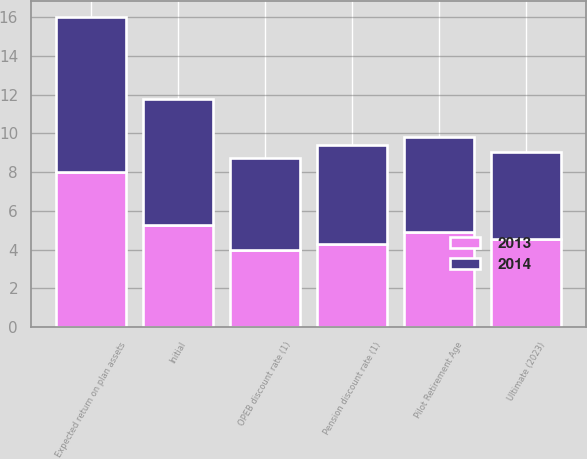Convert chart to OTSL. <chart><loc_0><loc_0><loc_500><loc_500><stacked_bar_chart><ecel><fcel>Pension discount rate (1)<fcel>OPEB discount rate (1)<fcel>Expected return on plan assets<fcel>Initial<fcel>Ultimate (2023)<fcel>Pilot Retirement Age<nl><fcel>2013<fcel>4.3<fcel>4<fcel>8<fcel>5.25<fcel>4.55<fcel>4.905<nl><fcel>2014<fcel>5.1<fcel>4.71<fcel>8<fcel>6.5<fcel>4.5<fcel>4.905<nl></chart> 